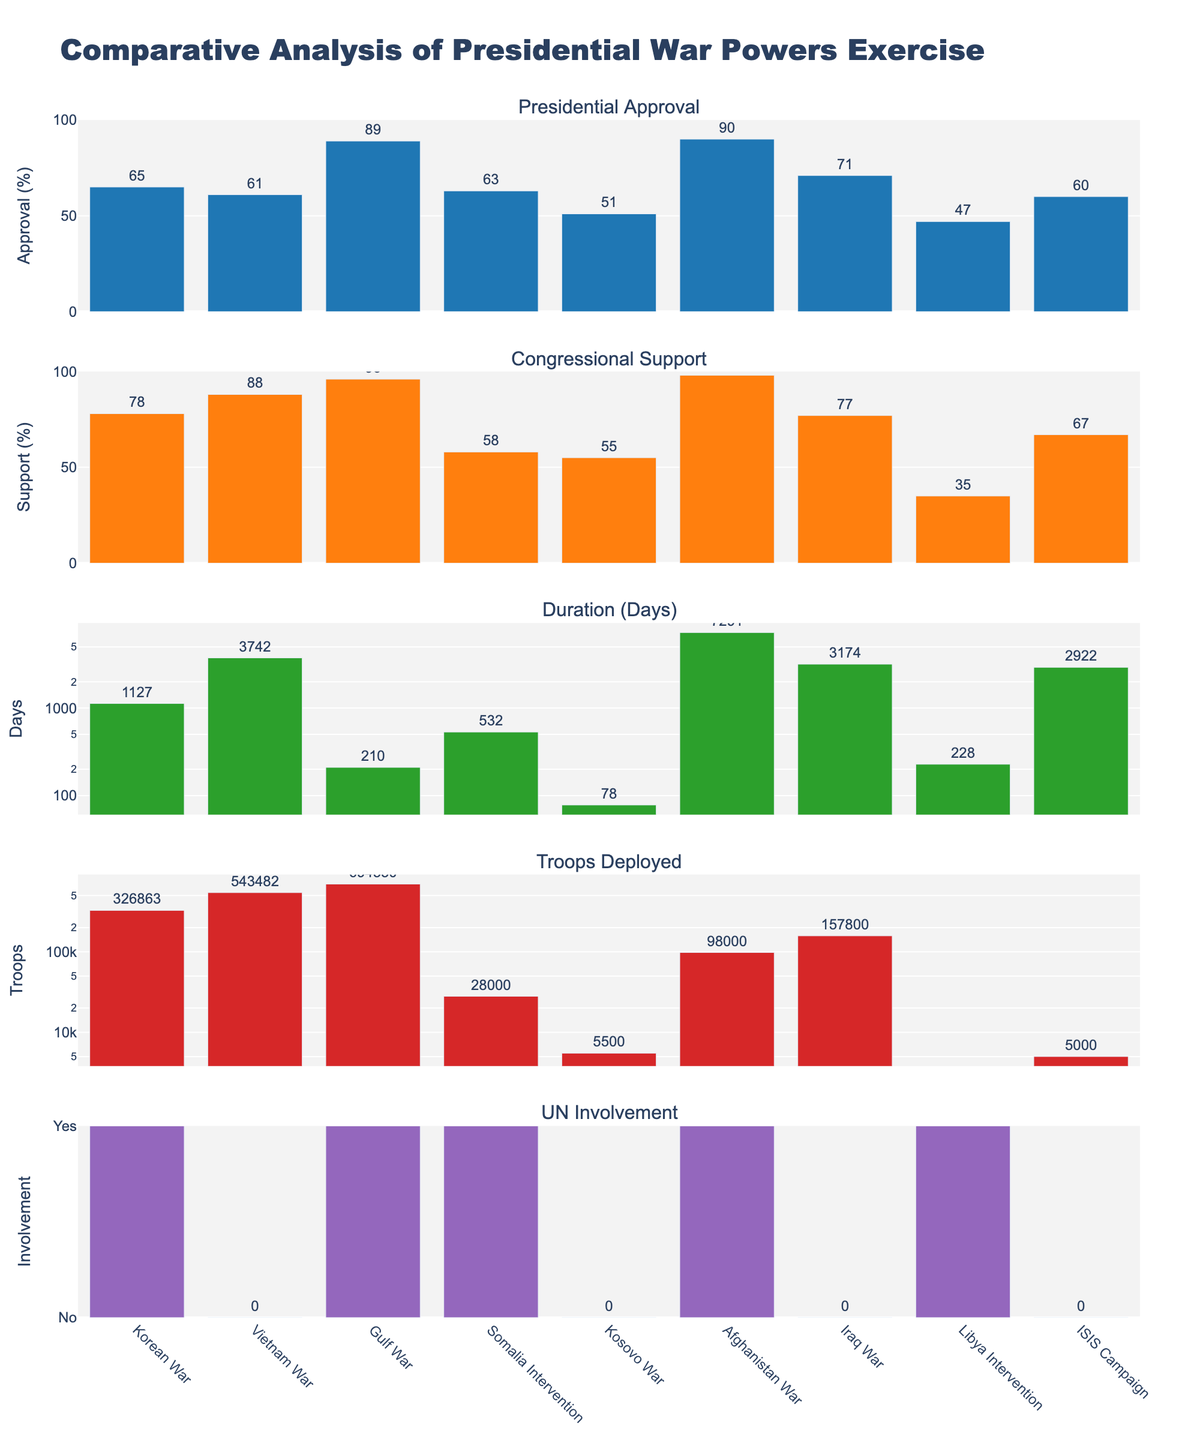What's the overall title of the figure? The overall title is displayed prominently at the top of the figure. It helps summarize what the figure is about.
Answer: Comparative Analysis of Presidential War Powers Exercise How many conflicts are analyzed across all subplots? Each subplot shares the same x-axis, which lists the conflicts being analyzed. You can count the number of conflict names displayed.
Answer: 9 Which conflict shows the highest presidential approval? In the first subplot titled "Presidential Approval," identify the tallest bar, which represents the highest approval rating.
Answer: Afghanistan War Which conflict had the longest duration in days? In the third subplot titled "Duration (Days)," look for the tallest bar. The y-axis log scale will indicate the conflict with the highest duration number.
Answer: Afghanistan War Which conflict had zero troops deployed? In the fourth subplot titled "Troops Deployed," any bar for a conflict that is not visible or at zero indicates no troops deployed.
Answer: Libya Intervention How long did the Gulf War last compared to the Iraq War in days? Look at the third subplot "Duration (Days)" for both conflicts' bars and compare their heights to understand the duration difference. The Gulf War bar is shorter than the Iraq War bar.
Answer: Iraq War lasted longer Which conflict had the least congressional support? In the second subplot titled "Congressional Support," find the shortest bar, indicating the least support among the conflicts.
Answer: Libya Intervention How many conflicts had UN involvement? In the fifth subplot titled "UN Involvement," count the number of conflicts with bars at the "Yes" level, indicating involvement.
Answer: 5 What's the average number of troops deployed in the Gulf War, Afghanistan War, and Iraq War? Identify the troop deployment values for these conflicts from the fourth subplot and calculate the average: (694550 + 98000 + 157800) / 3.
Answer: 316450 Which conflict had a higher UN involvement rate, Vietnam War or Somalia Intervention? In the fifth subplot "UN Involvement," check the bar positions for both conflicts. The highest value (1) indicates UN Involvement, while 0 indicates no involvement. Somalia Intervention had a bar at 1, and Vietnam War at 0.
Answer: Somalia Intervention 